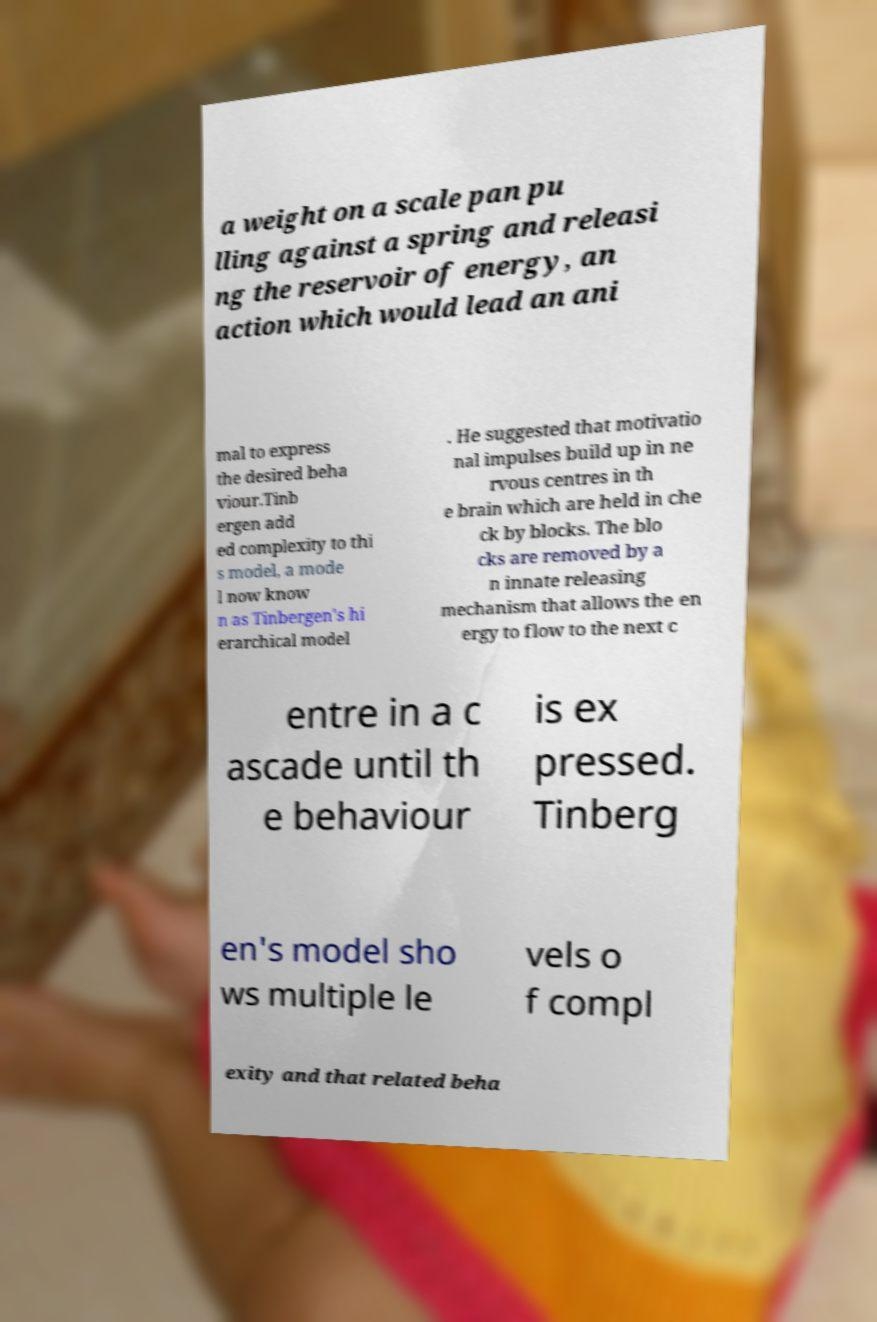Can you accurately transcribe the text from the provided image for me? a weight on a scale pan pu lling against a spring and releasi ng the reservoir of energy, an action which would lead an ani mal to express the desired beha viour.Tinb ergen add ed complexity to thi s model, a mode l now know n as Tinbergen's hi erarchical model . He suggested that motivatio nal impulses build up in ne rvous centres in th e brain which are held in che ck by blocks. The blo cks are removed by a n innate releasing mechanism that allows the en ergy to flow to the next c entre in a c ascade until th e behaviour is ex pressed. Tinberg en's model sho ws multiple le vels o f compl exity and that related beha 